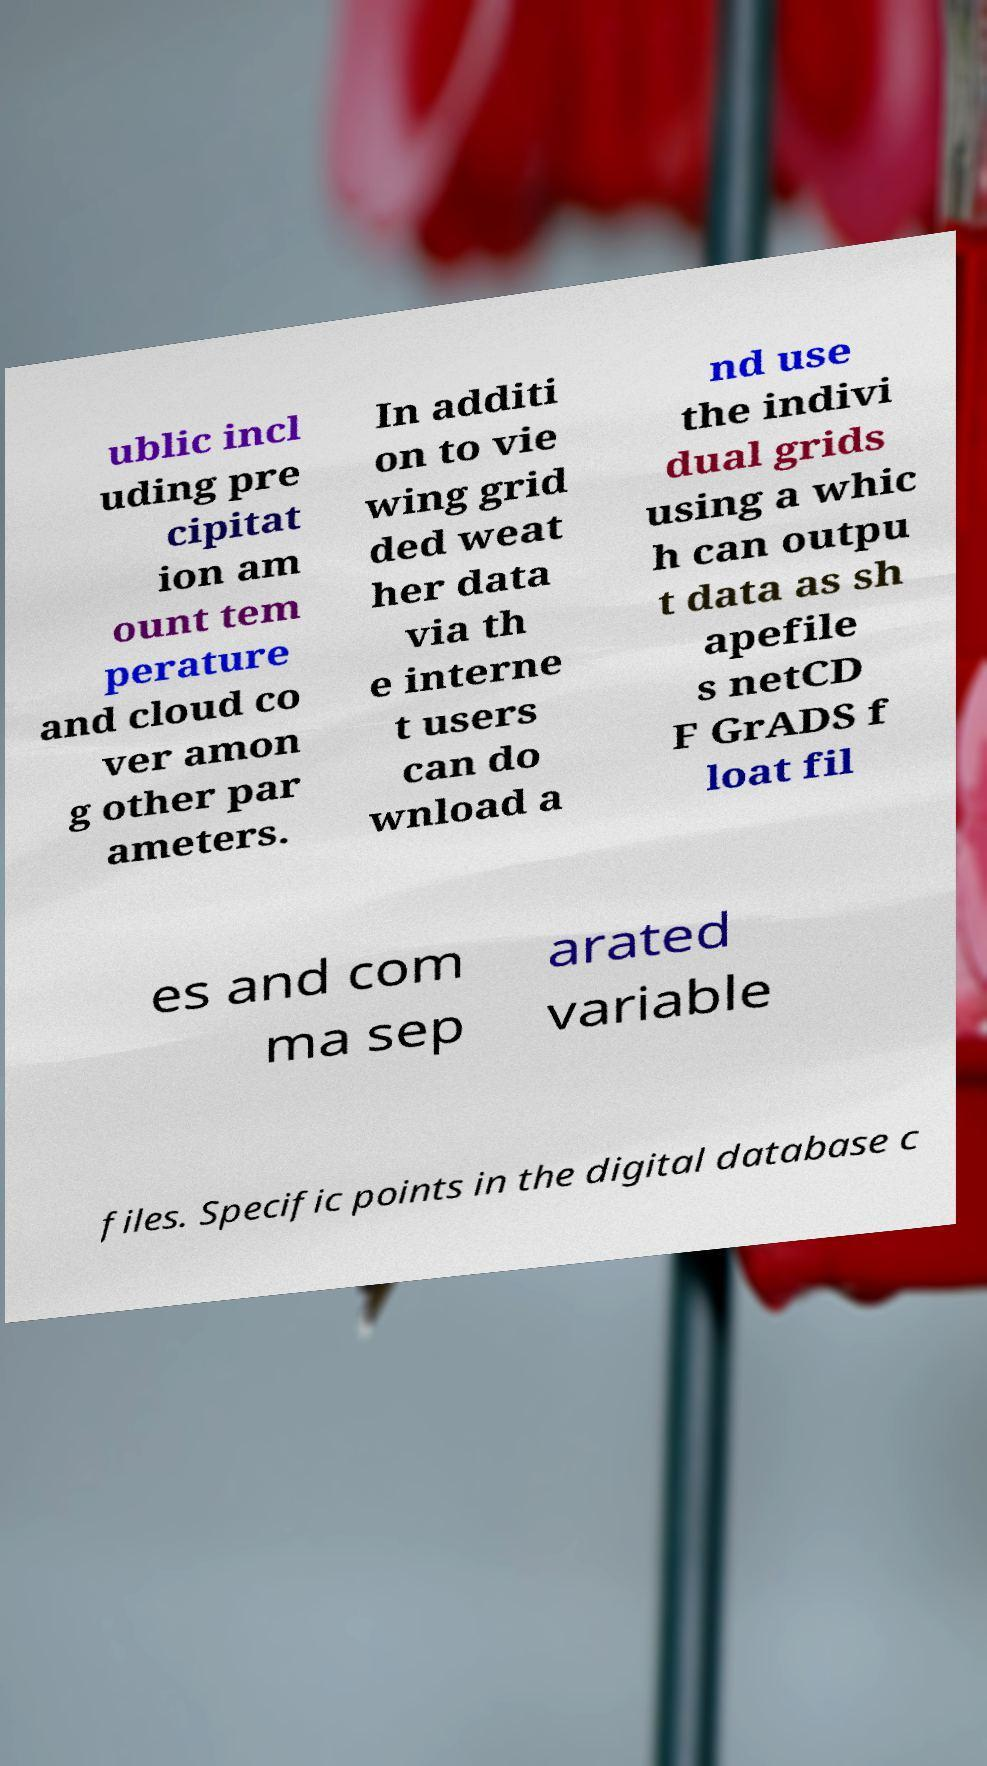For documentation purposes, I need the text within this image transcribed. Could you provide that? ublic incl uding pre cipitat ion am ount tem perature and cloud co ver amon g other par ameters. In additi on to vie wing grid ded weat her data via th e interne t users can do wnload a nd use the indivi dual grids using a whic h can outpu t data as sh apefile s netCD F GrADS f loat fil es and com ma sep arated variable files. Specific points in the digital database c 